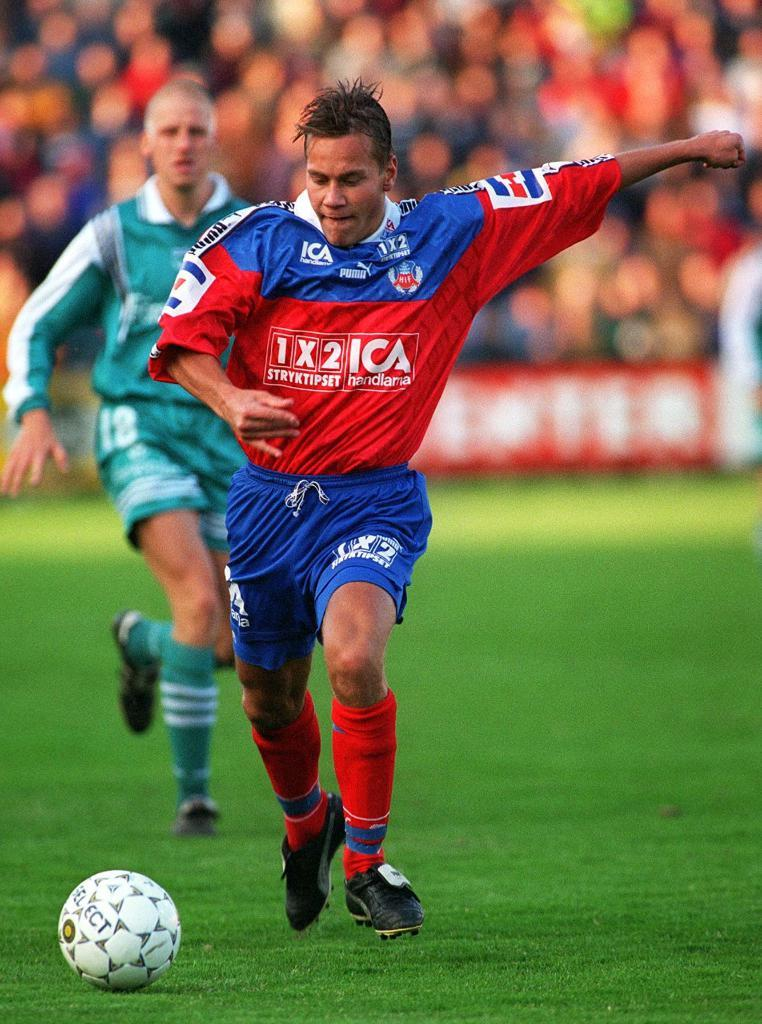<image>
Offer a succinct explanation of the picture presented. a person in s soccer jersey that says ICA on it 